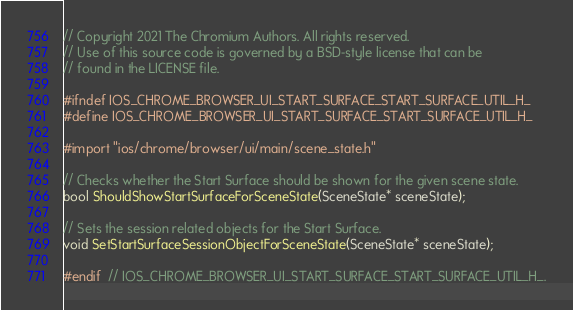<code> <loc_0><loc_0><loc_500><loc_500><_C_>// Copyright 2021 The Chromium Authors. All rights reserved.
// Use of this source code is governed by a BSD-style license that can be
// found in the LICENSE file.

#ifndef IOS_CHROME_BROWSER_UI_START_SURFACE_START_SURFACE_UTIL_H_
#define IOS_CHROME_BROWSER_UI_START_SURFACE_START_SURFACE_UTIL_H_

#import "ios/chrome/browser/ui/main/scene_state.h"

// Checks whether the Start Surface should be shown for the given scene state.
bool ShouldShowStartSurfaceForSceneState(SceneState* sceneState);

// Sets the session related objects for the Start Surface.
void SetStartSurfaceSessionObjectForSceneState(SceneState* sceneState);

#endif  // IOS_CHROME_BROWSER_UI_START_SURFACE_START_SURFACE_UTIL_H_.
</code> 